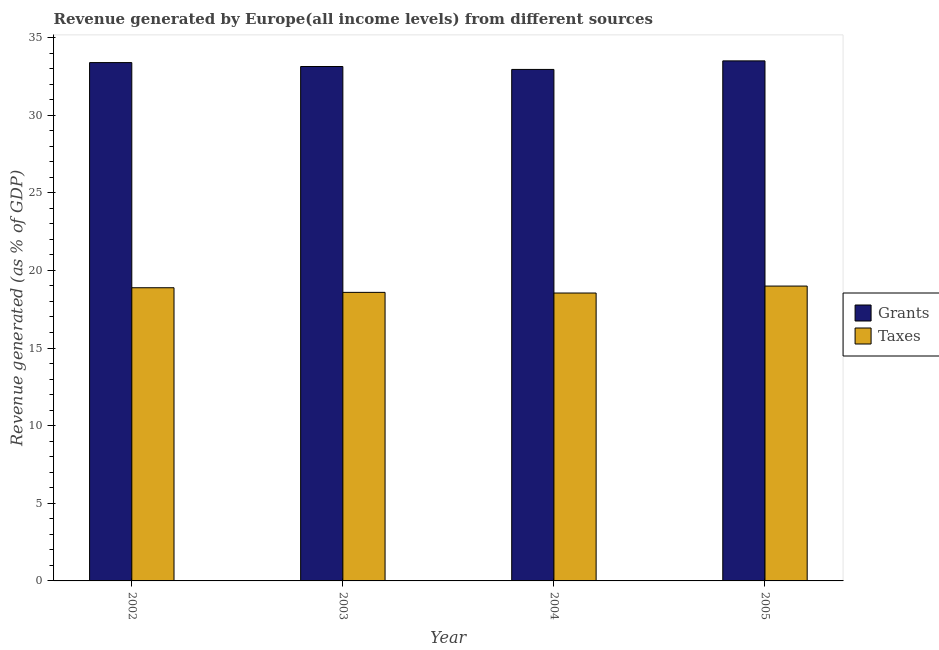Are the number of bars per tick equal to the number of legend labels?
Make the answer very short. Yes. How many bars are there on the 2nd tick from the left?
Ensure brevity in your answer.  2. What is the label of the 3rd group of bars from the left?
Provide a succinct answer. 2004. What is the revenue generated by grants in 2005?
Offer a terse response. 33.49. Across all years, what is the maximum revenue generated by taxes?
Keep it short and to the point. 18.99. Across all years, what is the minimum revenue generated by grants?
Keep it short and to the point. 32.94. In which year was the revenue generated by taxes minimum?
Ensure brevity in your answer.  2004. What is the total revenue generated by taxes in the graph?
Your answer should be compact. 75. What is the difference between the revenue generated by grants in 2002 and that in 2005?
Keep it short and to the point. -0.11. What is the difference between the revenue generated by taxes in 2005 and the revenue generated by grants in 2004?
Provide a short and direct response. 0.45. What is the average revenue generated by grants per year?
Keep it short and to the point. 33.24. In the year 2004, what is the difference between the revenue generated by grants and revenue generated by taxes?
Your answer should be compact. 0. What is the ratio of the revenue generated by taxes in 2002 to that in 2004?
Give a very brief answer. 1.02. Is the revenue generated by taxes in 2004 less than that in 2005?
Give a very brief answer. Yes. What is the difference between the highest and the second highest revenue generated by grants?
Your answer should be very brief. 0.11. What is the difference between the highest and the lowest revenue generated by taxes?
Your answer should be compact. 0.45. In how many years, is the revenue generated by taxes greater than the average revenue generated by taxes taken over all years?
Keep it short and to the point. 2. What does the 1st bar from the left in 2003 represents?
Your response must be concise. Grants. What does the 1st bar from the right in 2003 represents?
Offer a very short reply. Taxes. How many bars are there?
Offer a terse response. 8. How many years are there in the graph?
Your answer should be very brief. 4. Are the values on the major ticks of Y-axis written in scientific E-notation?
Your response must be concise. No. Does the graph contain grids?
Your answer should be compact. No. Where does the legend appear in the graph?
Your response must be concise. Center right. How many legend labels are there?
Make the answer very short. 2. How are the legend labels stacked?
Give a very brief answer. Vertical. What is the title of the graph?
Offer a very short reply. Revenue generated by Europe(all income levels) from different sources. What is the label or title of the Y-axis?
Provide a short and direct response. Revenue generated (as % of GDP). What is the Revenue generated (as % of GDP) of Grants in 2002?
Make the answer very short. 33.38. What is the Revenue generated (as % of GDP) of Taxes in 2002?
Ensure brevity in your answer.  18.88. What is the Revenue generated (as % of GDP) in Grants in 2003?
Provide a succinct answer. 33.13. What is the Revenue generated (as % of GDP) in Taxes in 2003?
Provide a short and direct response. 18.58. What is the Revenue generated (as % of GDP) in Grants in 2004?
Ensure brevity in your answer.  32.94. What is the Revenue generated (as % of GDP) of Taxes in 2004?
Keep it short and to the point. 18.54. What is the Revenue generated (as % of GDP) of Grants in 2005?
Your response must be concise. 33.49. What is the Revenue generated (as % of GDP) of Taxes in 2005?
Provide a short and direct response. 18.99. Across all years, what is the maximum Revenue generated (as % of GDP) of Grants?
Make the answer very short. 33.49. Across all years, what is the maximum Revenue generated (as % of GDP) of Taxes?
Your answer should be compact. 18.99. Across all years, what is the minimum Revenue generated (as % of GDP) in Grants?
Provide a succinct answer. 32.94. Across all years, what is the minimum Revenue generated (as % of GDP) of Taxes?
Your response must be concise. 18.54. What is the total Revenue generated (as % of GDP) in Grants in the graph?
Provide a succinct answer. 132.95. What is the total Revenue generated (as % of GDP) of Taxes in the graph?
Make the answer very short. 75. What is the difference between the Revenue generated (as % of GDP) in Grants in 2002 and that in 2003?
Offer a terse response. 0.25. What is the difference between the Revenue generated (as % of GDP) in Taxes in 2002 and that in 2003?
Your answer should be compact. 0.3. What is the difference between the Revenue generated (as % of GDP) of Grants in 2002 and that in 2004?
Ensure brevity in your answer.  0.44. What is the difference between the Revenue generated (as % of GDP) of Taxes in 2002 and that in 2004?
Your response must be concise. 0.34. What is the difference between the Revenue generated (as % of GDP) in Grants in 2002 and that in 2005?
Your response must be concise. -0.11. What is the difference between the Revenue generated (as % of GDP) in Taxes in 2002 and that in 2005?
Offer a very short reply. -0.11. What is the difference between the Revenue generated (as % of GDP) of Grants in 2003 and that in 2004?
Provide a short and direct response. 0.19. What is the difference between the Revenue generated (as % of GDP) in Taxes in 2003 and that in 2004?
Offer a terse response. 0.04. What is the difference between the Revenue generated (as % of GDP) of Grants in 2003 and that in 2005?
Offer a very short reply. -0.36. What is the difference between the Revenue generated (as % of GDP) of Taxes in 2003 and that in 2005?
Keep it short and to the point. -0.4. What is the difference between the Revenue generated (as % of GDP) of Grants in 2004 and that in 2005?
Make the answer very short. -0.55. What is the difference between the Revenue generated (as % of GDP) in Taxes in 2004 and that in 2005?
Provide a succinct answer. -0.45. What is the difference between the Revenue generated (as % of GDP) of Grants in 2002 and the Revenue generated (as % of GDP) of Taxes in 2003?
Provide a short and direct response. 14.8. What is the difference between the Revenue generated (as % of GDP) of Grants in 2002 and the Revenue generated (as % of GDP) of Taxes in 2004?
Your answer should be very brief. 14.84. What is the difference between the Revenue generated (as % of GDP) of Grants in 2002 and the Revenue generated (as % of GDP) of Taxes in 2005?
Ensure brevity in your answer.  14.39. What is the difference between the Revenue generated (as % of GDP) of Grants in 2003 and the Revenue generated (as % of GDP) of Taxes in 2004?
Make the answer very short. 14.59. What is the difference between the Revenue generated (as % of GDP) in Grants in 2003 and the Revenue generated (as % of GDP) in Taxes in 2005?
Provide a short and direct response. 14.14. What is the difference between the Revenue generated (as % of GDP) of Grants in 2004 and the Revenue generated (as % of GDP) of Taxes in 2005?
Make the answer very short. 13.95. What is the average Revenue generated (as % of GDP) in Grants per year?
Offer a very short reply. 33.24. What is the average Revenue generated (as % of GDP) in Taxes per year?
Offer a very short reply. 18.75. In the year 2002, what is the difference between the Revenue generated (as % of GDP) of Grants and Revenue generated (as % of GDP) of Taxes?
Offer a very short reply. 14.5. In the year 2003, what is the difference between the Revenue generated (as % of GDP) of Grants and Revenue generated (as % of GDP) of Taxes?
Provide a short and direct response. 14.55. In the year 2004, what is the difference between the Revenue generated (as % of GDP) in Grants and Revenue generated (as % of GDP) in Taxes?
Make the answer very short. 14.4. In the year 2005, what is the difference between the Revenue generated (as % of GDP) in Grants and Revenue generated (as % of GDP) in Taxes?
Provide a short and direct response. 14.5. What is the ratio of the Revenue generated (as % of GDP) in Grants in 2002 to that in 2003?
Your answer should be compact. 1.01. What is the ratio of the Revenue generated (as % of GDP) in Taxes in 2002 to that in 2003?
Make the answer very short. 1.02. What is the ratio of the Revenue generated (as % of GDP) in Grants in 2002 to that in 2004?
Ensure brevity in your answer.  1.01. What is the ratio of the Revenue generated (as % of GDP) of Taxes in 2002 to that in 2004?
Your answer should be compact. 1.02. What is the ratio of the Revenue generated (as % of GDP) in Grants in 2002 to that in 2005?
Offer a very short reply. 1. What is the ratio of the Revenue generated (as % of GDP) of Taxes in 2003 to that in 2004?
Your response must be concise. 1. What is the ratio of the Revenue generated (as % of GDP) of Grants in 2003 to that in 2005?
Provide a short and direct response. 0.99. What is the ratio of the Revenue generated (as % of GDP) of Taxes in 2003 to that in 2005?
Your answer should be very brief. 0.98. What is the ratio of the Revenue generated (as % of GDP) in Grants in 2004 to that in 2005?
Keep it short and to the point. 0.98. What is the ratio of the Revenue generated (as % of GDP) in Taxes in 2004 to that in 2005?
Provide a short and direct response. 0.98. What is the difference between the highest and the second highest Revenue generated (as % of GDP) in Grants?
Keep it short and to the point. 0.11. What is the difference between the highest and the second highest Revenue generated (as % of GDP) of Taxes?
Offer a terse response. 0.11. What is the difference between the highest and the lowest Revenue generated (as % of GDP) in Grants?
Offer a terse response. 0.55. What is the difference between the highest and the lowest Revenue generated (as % of GDP) of Taxes?
Keep it short and to the point. 0.45. 